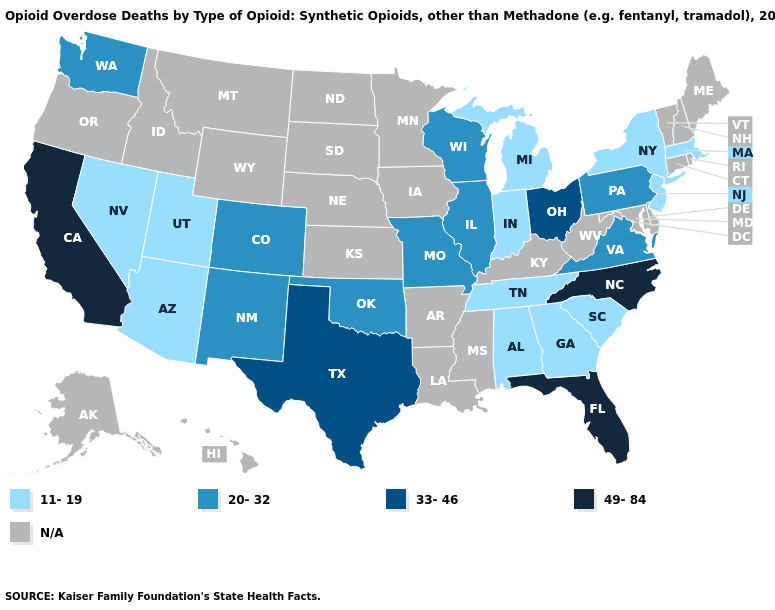What is the value of Oregon?
Short answer required. N/A. What is the highest value in the USA?
Keep it brief. 49-84. Which states have the lowest value in the West?
Answer briefly. Arizona, Nevada, Utah. Which states have the lowest value in the Northeast?
Write a very short answer. Massachusetts, New Jersey, New York. What is the value of Vermont?
Short answer required. N/A. What is the value of Hawaii?
Keep it brief. N/A. What is the highest value in the South ?
Give a very brief answer. 49-84. Does the map have missing data?
Write a very short answer. Yes. Is the legend a continuous bar?
Be succinct. No. What is the value of Indiana?
Give a very brief answer. 11-19. Name the states that have a value in the range 49-84?
Write a very short answer. California, Florida, North Carolina. Does Florida have the highest value in the South?
Concise answer only. Yes. Among the states that border Kentucky , does Indiana have the lowest value?
Quick response, please. Yes. 